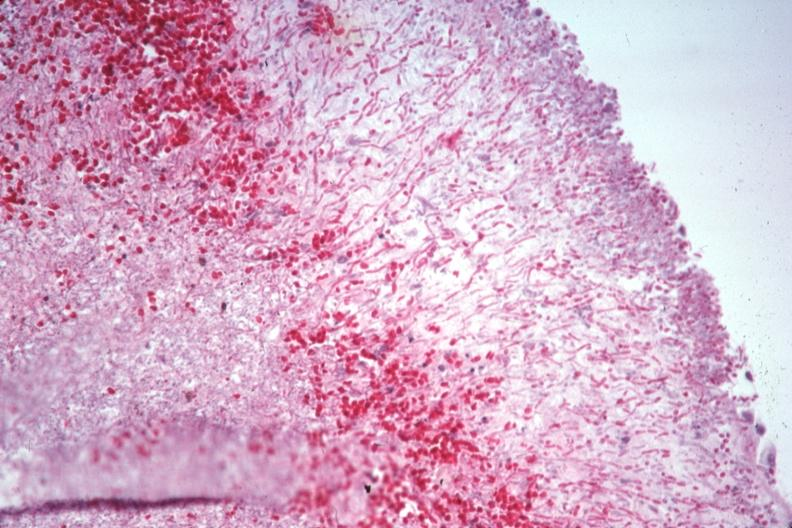s candida present?
Answer the question using a single word or phrase. Yes 